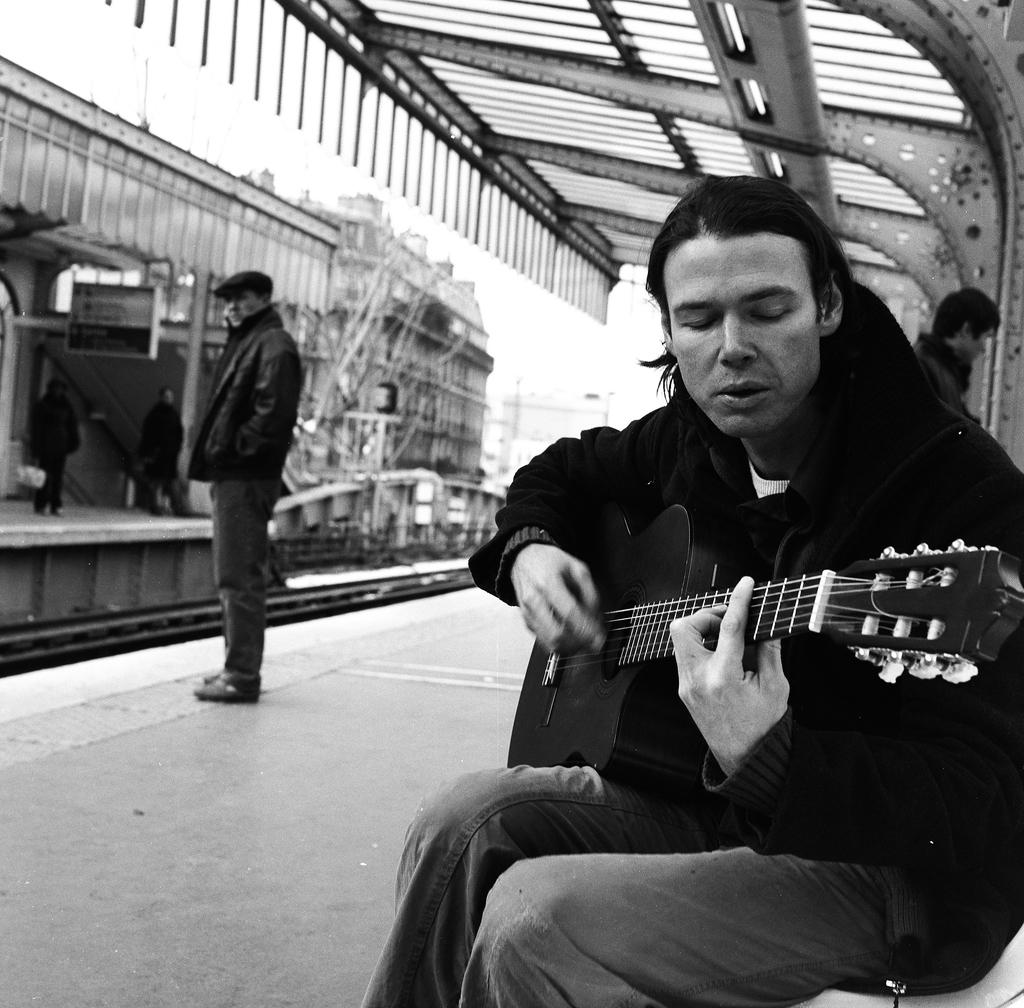How many people are in the image? There are people in the image, but the exact number is not specified. What is the man in the image doing? The man is sitting and holding a guitar. What are the other people in the image doing? The rest of the people are standing. How many pies are on the neck of the thing in the image? There are no pies or things mentioned in the image; it only features people, including a man holding a guitar. 